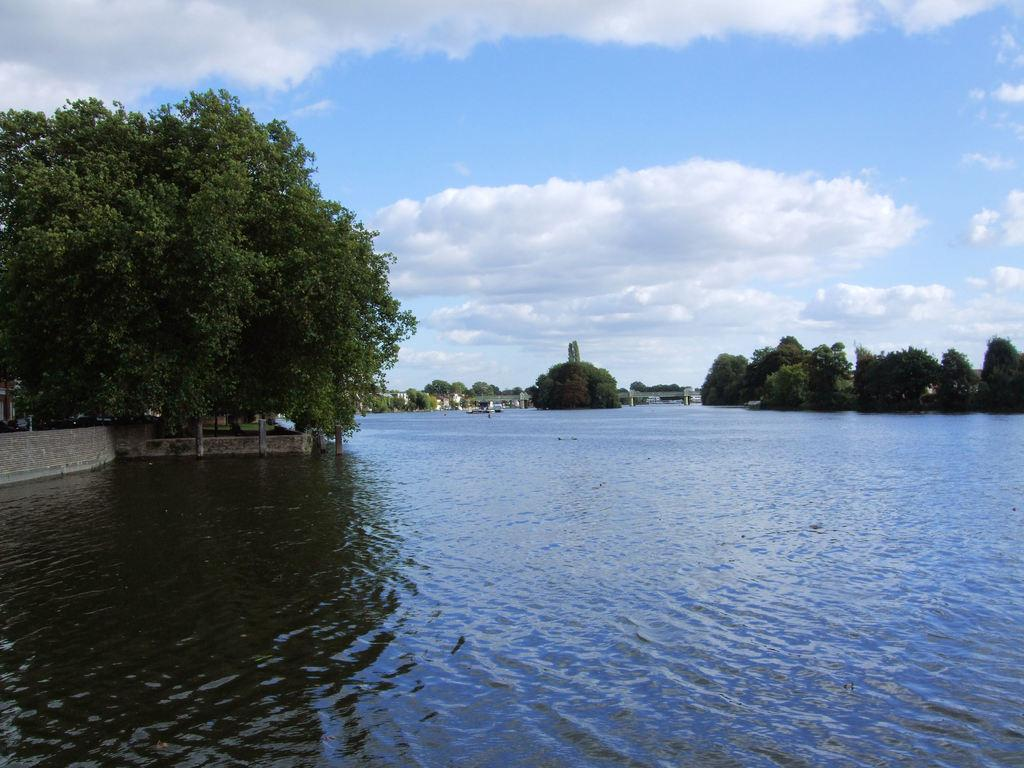What is the primary element visible in the image? There is water in the image. What type of vegetation can be seen in the image? There are trees in the image. What structure is present in the image? There is a wall in the image. What is visible in the background of the image? The sky is visible in the background of the image. What can be observed in the sky? Clouds are present in the sky. Where is the house located in the image? There is no house present in the image. What type of market can be seen in the image? There is no market present in the image. 